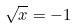Convert formula to latex. <formula><loc_0><loc_0><loc_500><loc_500>\sqrt { x } = - 1</formula> 